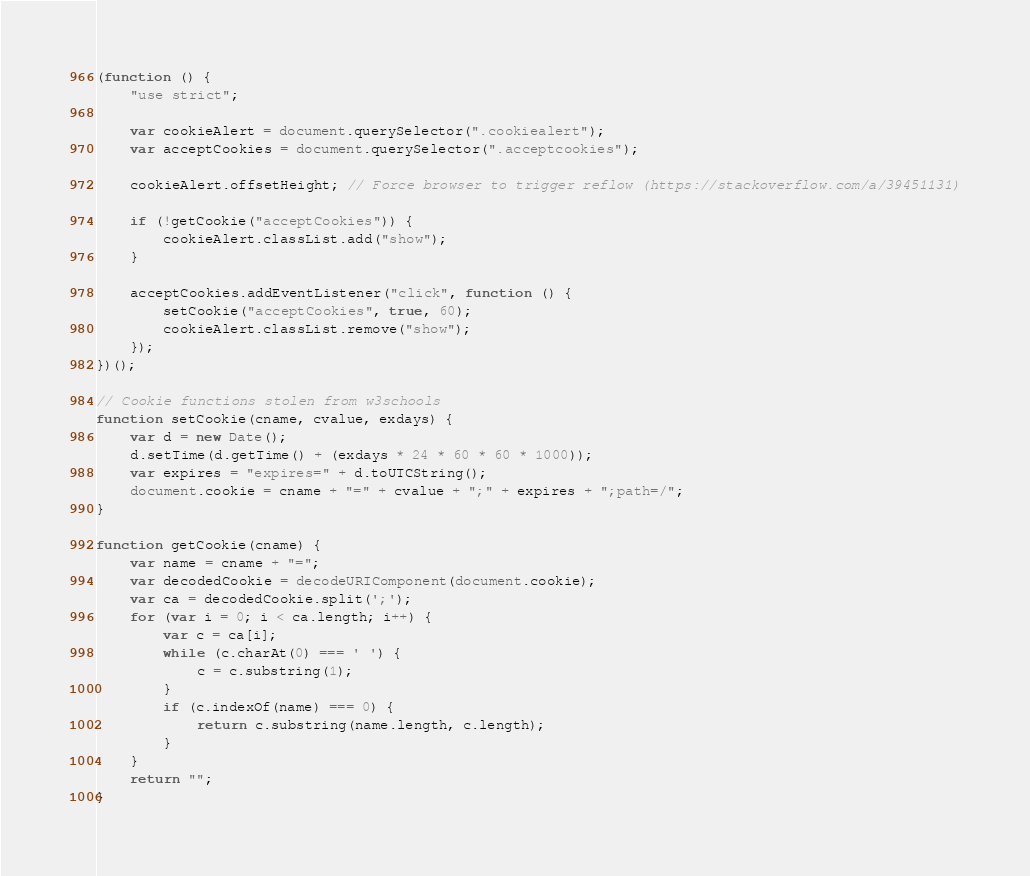<code> <loc_0><loc_0><loc_500><loc_500><_JavaScript_>(function () {
    "use strict";

    var cookieAlert = document.querySelector(".cookiealert");
    var acceptCookies = document.querySelector(".acceptcookies");

    cookieAlert.offsetHeight; // Force browser to trigger reflow (https://stackoverflow.com/a/39451131)

    if (!getCookie("acceptCookies")) {
        cookieAlert.classList.add("show");
    }

    acceptCookies.addEventListener("click", function () {
        setCookie("acceptCookies", true, 60);
        cookieAlert.classList.remove("show");
    });
})();

// Cookie functions stolen from w3schools
function setCookie(cname, cvalue, exdays) {
    var d = new Date();
    d.setTime(d.getTime() + (exdays * 24 * 60 * 60 * 1000));
    var expires = "expires=" + d.toUTCString();
    document.cookie = cname + "=" + cvalue + ";" + expires + ";path=/";
}

function getCookie(cname) {
    var name = cname + "=";
    var decodedCookie = decodeURIComponent(document.cookie);
    var ca = decodedCookie.split(';');
    for (var i = 0; i < ca.length; i++) {
        var c = ca[i];
        while (c.charAt(0) === ' ') {
            c = c.substring(1);
        }
        if (c.indexOf(name) === 0) {
            return c.substring(name.length, c.length);
        }
    }
    return "";
}
</code> 